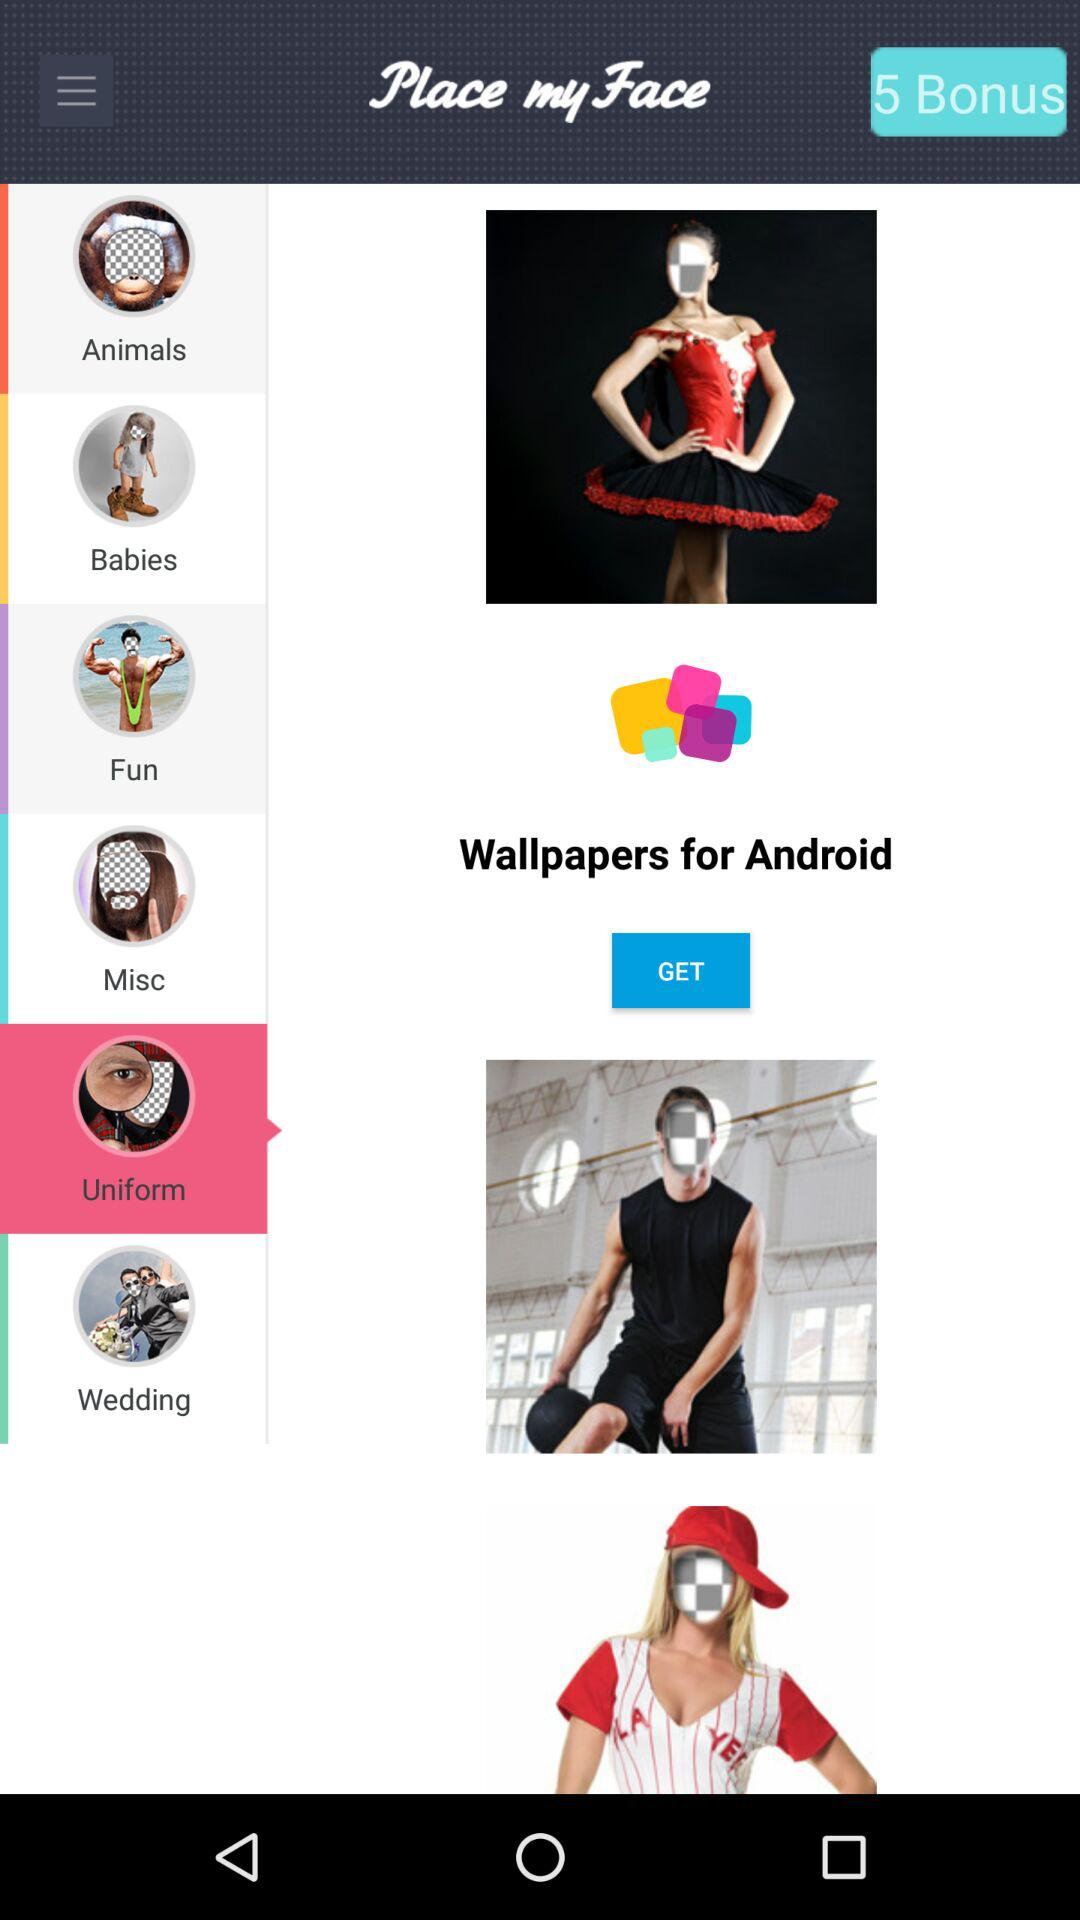Which option is selected? The selected option is "Uniform". 